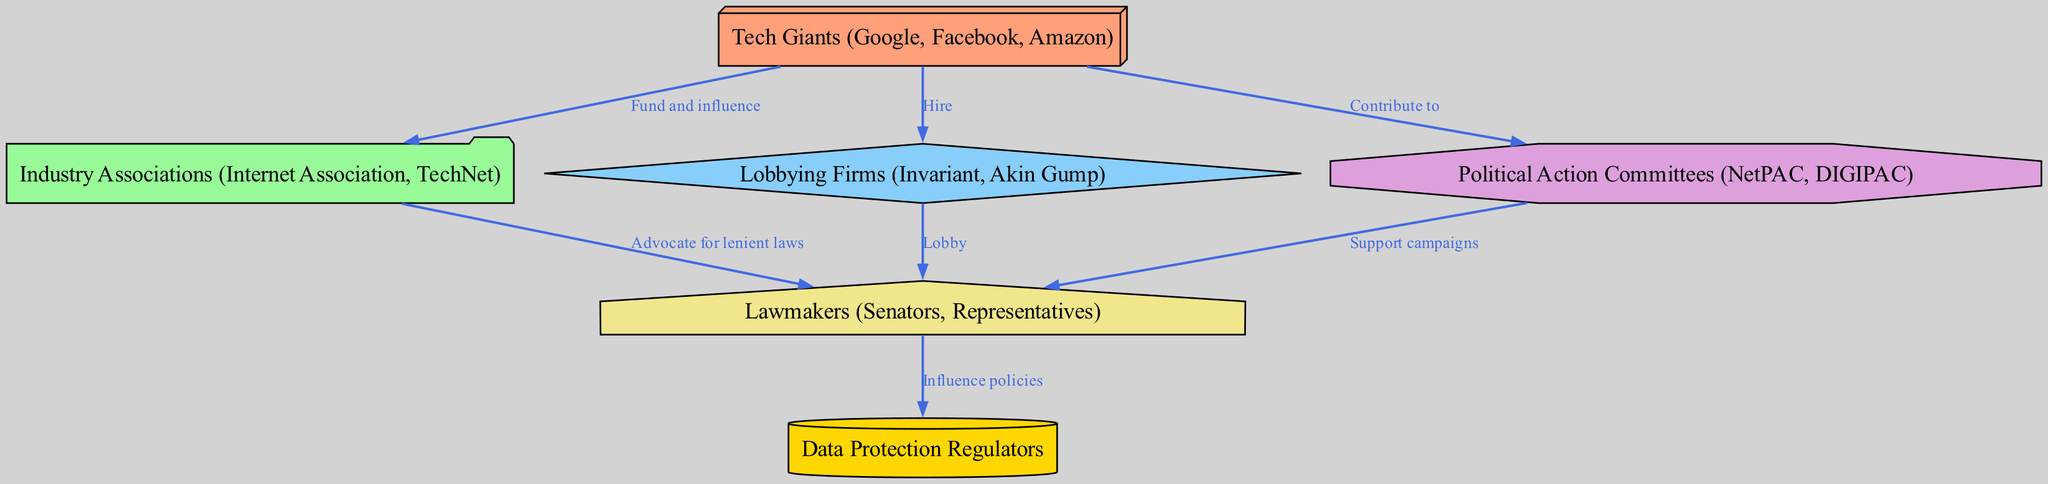What are the main entities represented in the diagram? The diagram shows six main entities: Tech Giants, Industry Associations, Lobbying Firms, Political Action Committees, Lawmakers, and Data Protection Regulators.
Answer: Tech Giants, Industry Associations, Lobbying Firms, Political Action Committees, Lawmakers, Data Protection Regulators How many nodes are there in the diagram? The diagram illustrates a total of six nodes representing different entities involved in lobbying for lenient data regulations.
Answer: 6 Which entity influences policies of Data Protection Regulators? The diagram indicates that the entity 'Lawmakers' has a direct influence on the policies of 'Data Protection Regulators' as represented by the directed edge connecting them.
Answer: Lawmakers What is the relationship between Tech Giants and Lobbying Firms? According to the diagram, Tech Giants hire Lobbying Firms to assist in their lobbying efforts, which is visualized by the directional edge connecting them.
Answer: Hire Who advocates for lenient laws to Lawmakers? The diagram shows that Industry Associations advocate for lenient laws to Lawmakers, represented by a directed edge from Industry Associations to Lawmakers.
Answer: Industry Associations What is the primary function of Political Action Committees in this food chain? The diagram indicates that Political Action Committees support the campaigns of Lawmakers, signifying their role in backing political efforts.
Answer: Support campaigns Which two entities directly connect Tech Giants and Lawmakers? The diagram illustrates that both Industry Associations and Lobbying Firms directly connect Tech Giants to Lawmakers, highlighting their intermediary roles.
Answer: Industry Associations, Lobbying Firms What do Lobbying Firms do in relation to Lawmakers? The diagram indicates that Lobbying Firms lobby Lawmakers, establishing a direct link and showing their function in the lobbying process.
Answer: Lobby How do Tech Giants influence Industry Associations? The diagram shows that Tech Giants fund and influence Industry Associations, indicating a support relationship between them.
Answer: Fund and influence 